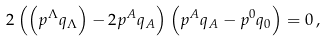<formula> <loc_0><loc_0><loc_500><loc_500>2 \left ( \left ( p ^ { \Lambda } q _ { \Lambda } \right ) - 2 p ^ { A } q _ { A } \right ) \left ( p ^ { A } q _ { A } - p ^ { 0 } q _ { 0 } \right ) = 0 \, ,</formula> 